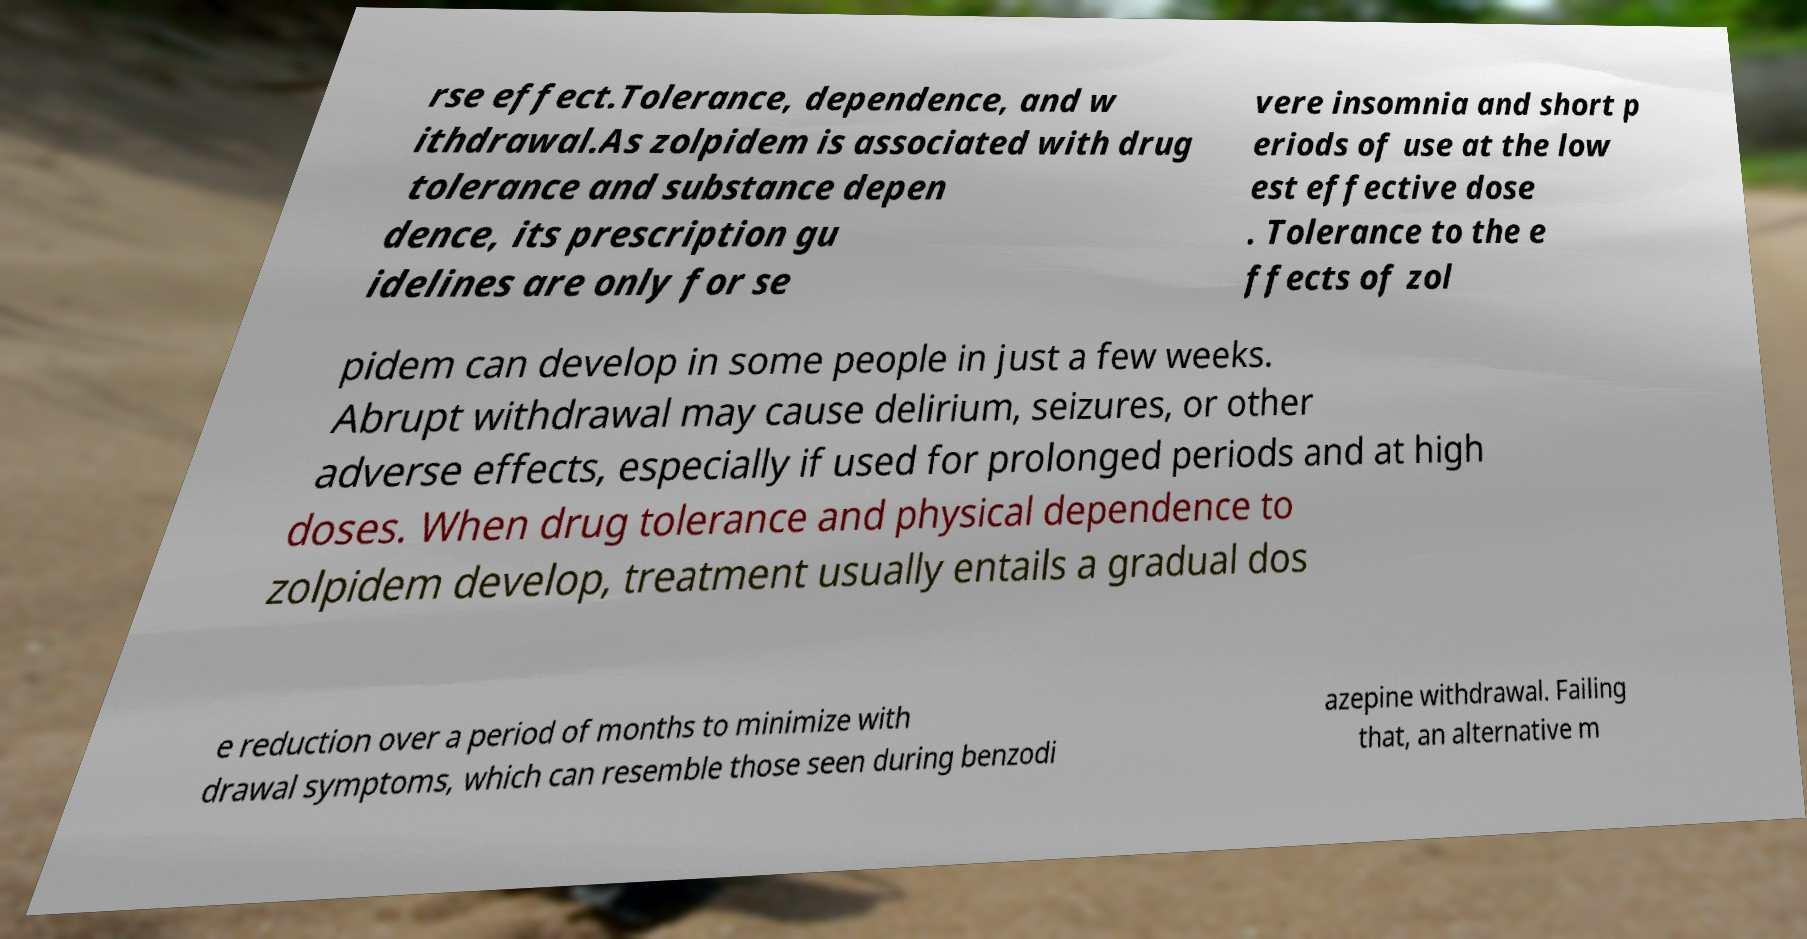Can you read and provide the text displayed in the image?This photo seems to have some interesting text. Can you extract and type it out for me? rse effect.Tolerance, dependence, and w ithdrawal.As zolpidem is associated with drug tolerance and substance depen dence, its prescription gu idelines are only for se vere insomnia and short p eriods of use at the low est effective dose . Tolerance to the e ffects of zol pidem can develop in some people in just a few weeks. Abrupt withdrawal may cause delirium, seizures, or other adverse effects, especially if used for prolonged periods and at high doses. When drug tolerance and physical dependence to zolpidem develop, treatment usually entails a gradual dos e reduction over a period of months to minimize with drawal symptoms, which can resemble those seen during benzodi azepine withdrawal. Failing that, an alternative m 